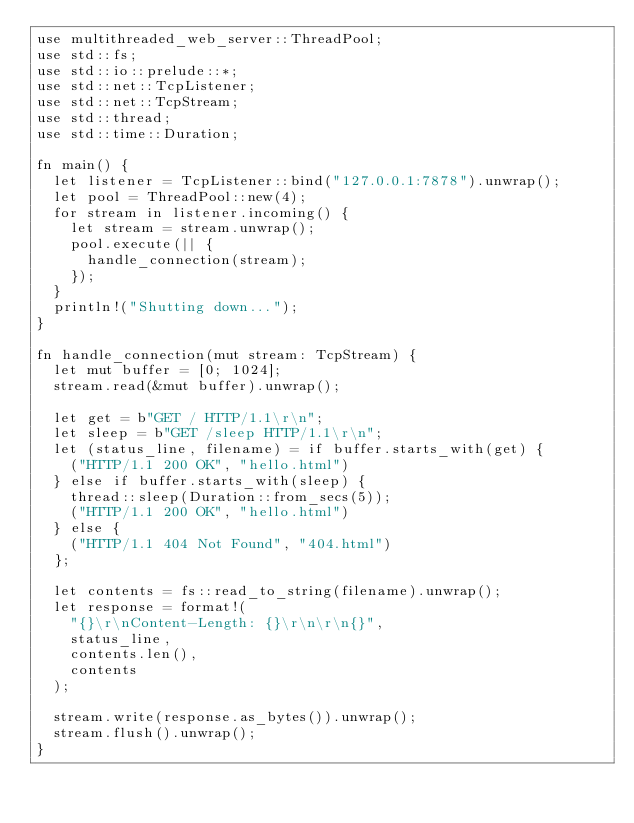<code> <loc_0><loc_0><loc_500><loc_500><_Rust_>use multithreaded_web_server::ThreadPool;
use std::fs;
use std::io::prelude::*;
use std::net::TcpListener;
use std::net::TcpStream;
use std::thread;
use std::time::Duration;

fn main() {
  let listener = TcpListener::bind("127.0.0.1:7878").unwrap();
  let pool = ThreadPool::new(4);
  for stream in listener.incoming() {
    let stream = stream.unwrap();
    pool.execute(|| {
      handle_connection(stream);
    });
  }
  println!("Shutting down...");
}

fn handle_connection(mut stream: TcpStream) {
  let mut buffer = [0; 1024];
  stream.read(&mut buffer).unwrap();

  let get = b"GET / HTTP/1.1\r\n";
  let sleep = b"GET /sleep HTTP/1.1\r\n";
  let (status_line, filename) = if buffer.starts_with(get) {
    ("HTTP/1.1 200 OK", "hello.html")
  } else if buffer.starts_with(sleep) {
    thread::sleep(Duration::from_secs(5));
    ("HTTP/1.1 200 OK", "hello.html")
  } else {
    ("HTTP/1.1 404 Not Found", "404.html")
  };

  let contents = fs::read_to_string(filename).unwrap();
  let response = format!(
    "{}\r\nContent-Length: {}\r\n\r\n{}",
    status_line,
    contents.len(),
    contents
  );

  stream.write(response.as_bytes()).unwrap();
  stream.flush().unwrap();
}
</code> 